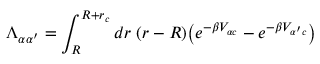Convert formula to latex. <formula><loc_0><loc_0><loc_500><loc_500>\Lambda _ { \alpha \alpha ^ { \prime } } = \int _ { R } ^ { R + r _ { c } } d r \, ( r - R ) \left ( e ^ { - \beta V _ { \alpha c } } - e ^ { - \beta V _ { \alpha ^ { \prime } c } } \right )</formula> 